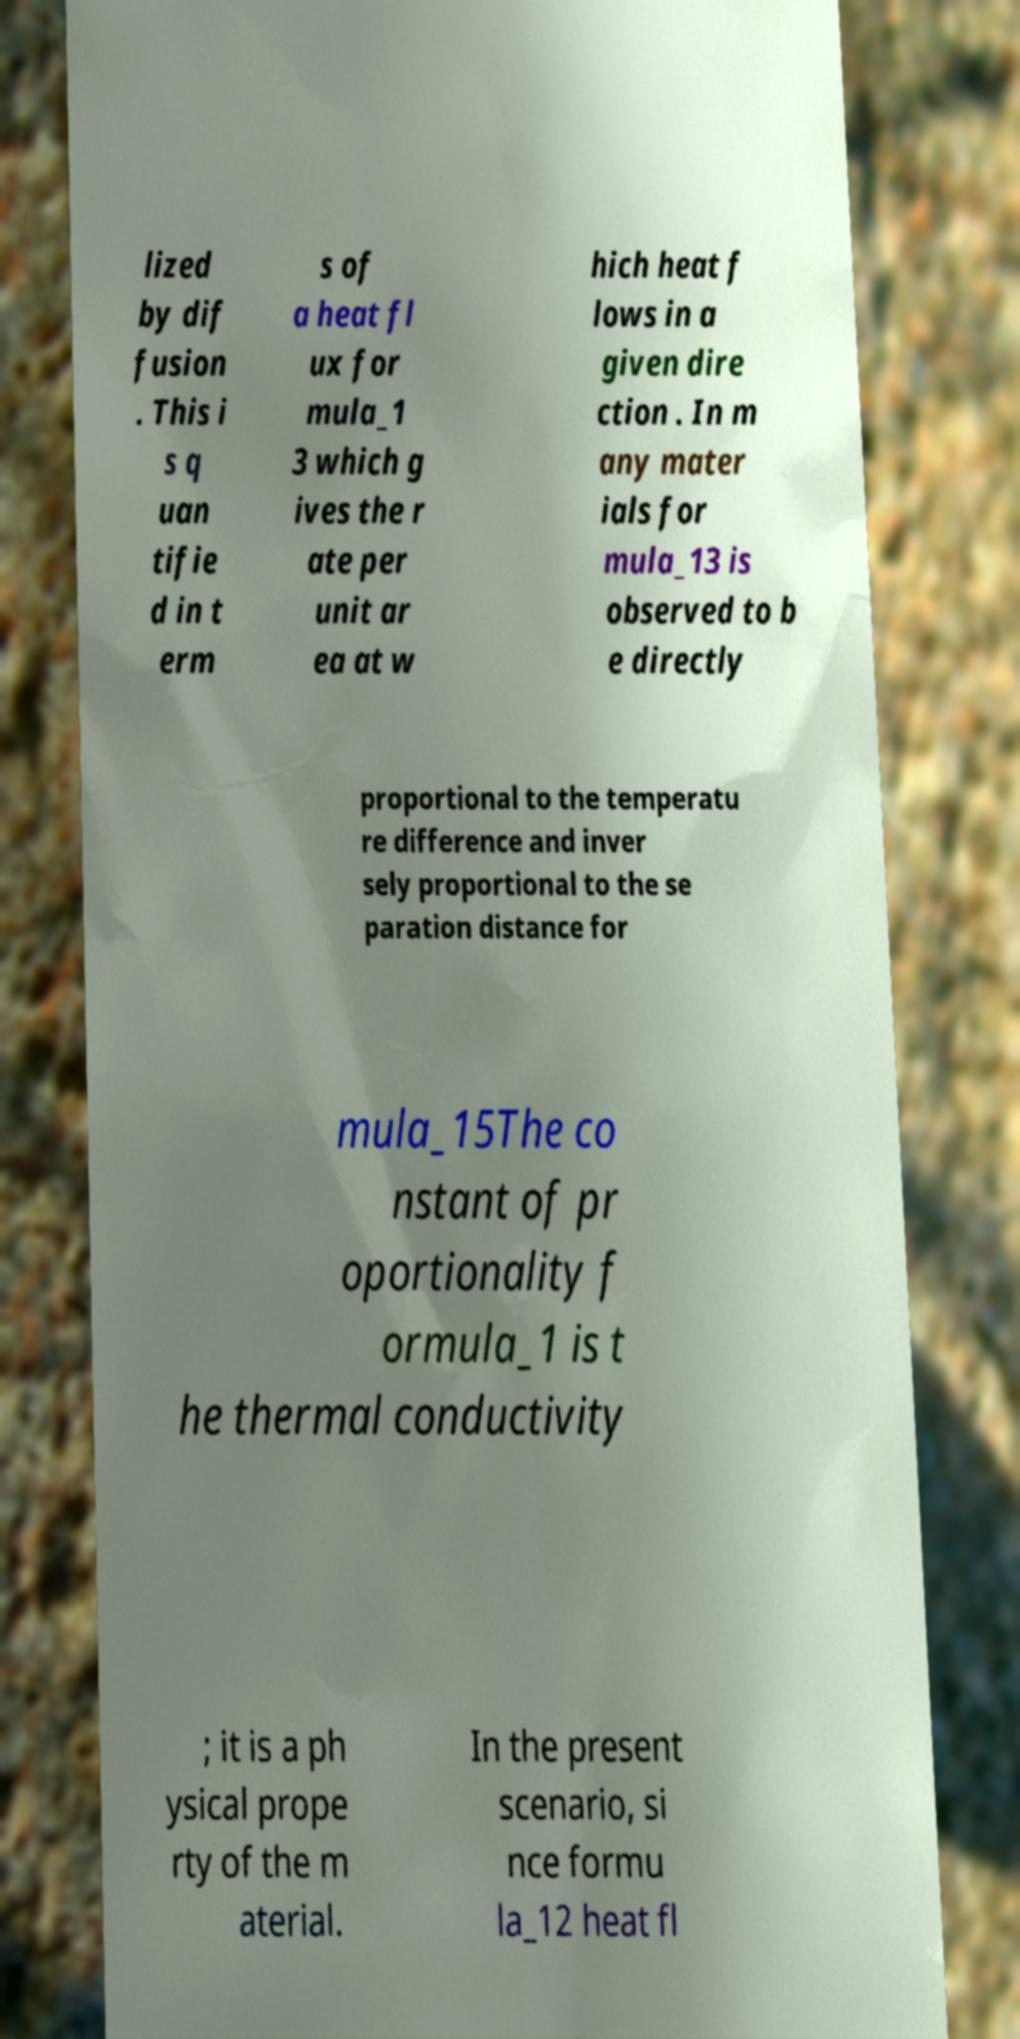Could you assist in decoding the text presented in this image and type it out clearly? lized by dif fusion . This i s q uan tifie d in t erm s of a heat fl ux for mula_1 3 which g ives the r ate per unit ar ea at w hich heat f lows in a given dire ction . In m any mater ials for mula_13 is observed to b e directly proportional to the temperatu re difference and inver sely proportional to the se paration distance for mula_15The co nstant of pr oportionality f ormula_1 is t he thermal conductivity ; it is a ph ysical prope rty of the m aterial. In the present scenario, si nce formu la_12 heat fl 